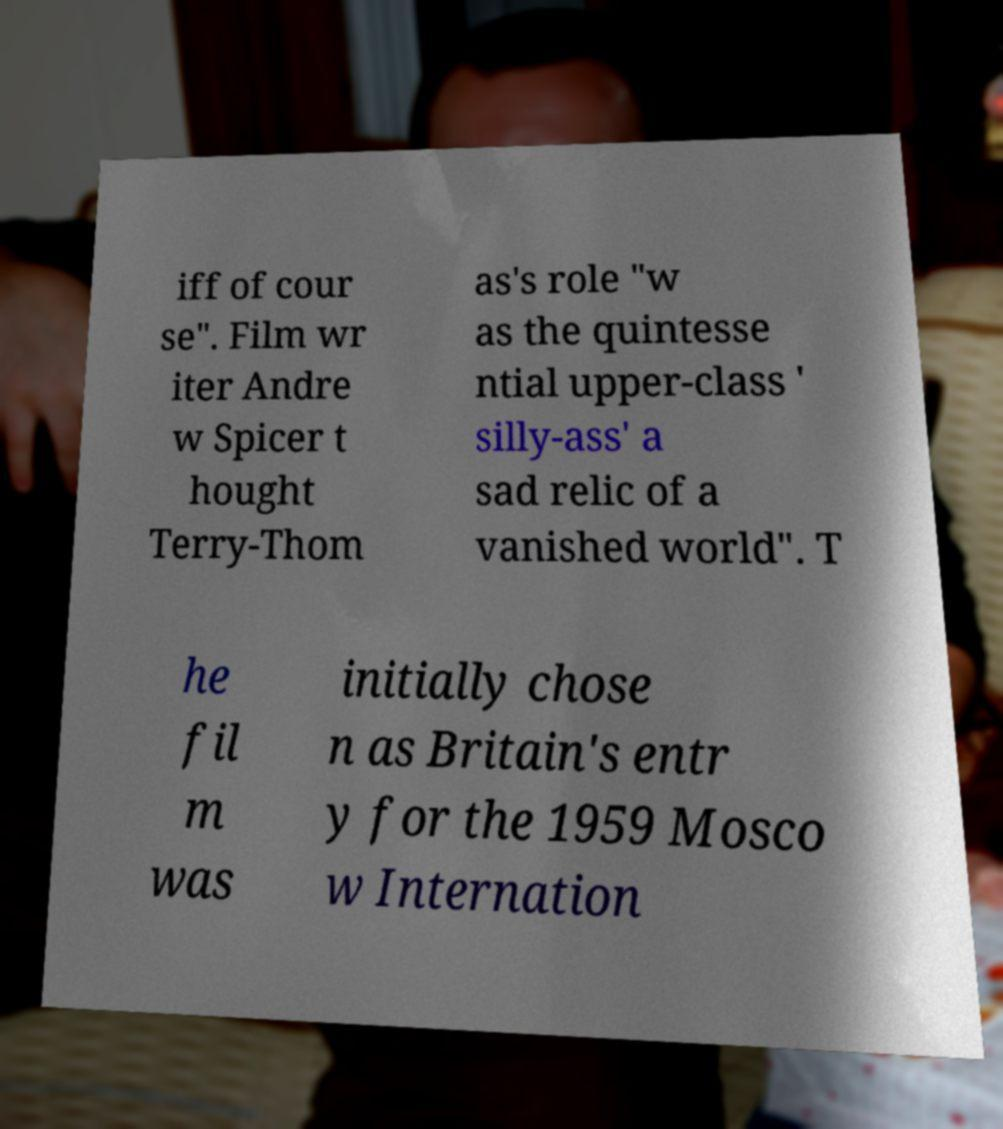Could you assist in decoding the text presented in this image and type it out clearly? iff of cour se". Film wr iter Andre w Spicer t hought Terry-Thom as's role "w as the quintesse ntial upper-class ' silly-ass' a sad relic of a vanished world". T he fil m was initially chose n as Britain's entr y for the 1959 Mosco w Internation 